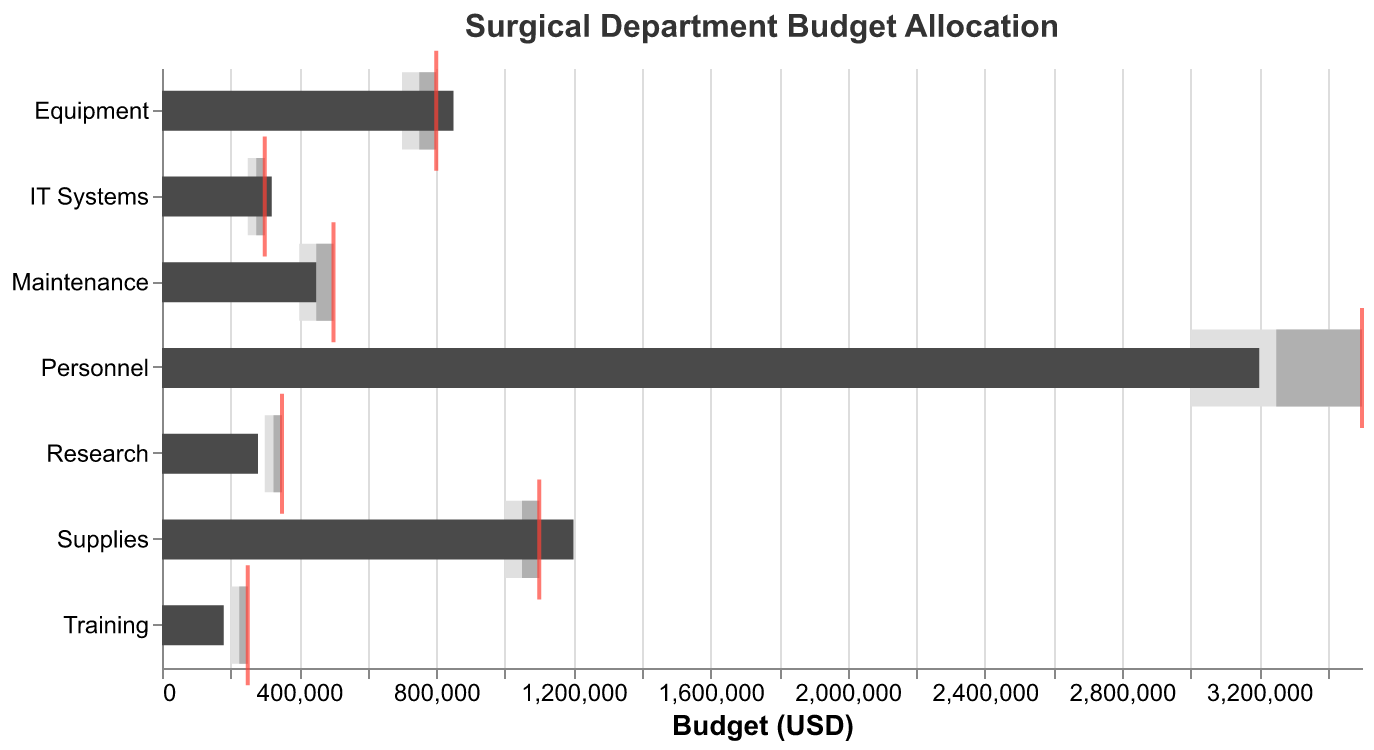What is the actual expenditure on personnel compared to its target? The actual expenditure on personnel is $3,200,000, while the target is $3,500,000. The actual value is indicated by the dark gray bar, and the target by the red tick mark.
Answer: $3,200,000 vs $3,500,000 Which category has the highest actual expenditure? The category with the highest actual expenditure is Personnel, with $3,200,000. This can be seen by comparing the length of the dark gray bars for each category.
Answer: Personnel Did the actual expenditure on equipment meet the target? Yes, the actual expenditure on equipment exceeded the target. The actual expenditure is $850,000, and the target is $800,000, as indicated by the dark gray bar surpassing the red tick mark.
Answer: Yes How much more did the actual expenditure on supplies exceed its target? The actual expenditure on supplies is $1,200,000, while the target is $1,100,000. The difference is calculated as $1,200,000 - $1,100,000 = $100,000.
Answer: $100,000 In which categories did the actual expenditure not meet the threshold 1 value? The categories where the actual expenditure did not meet the threshold 1 value are Training and Research. This can be seen because the dark gray bars for these categories do not reach the left edge of the lightest gray bars.
Answer: Training, Research What is the difference between the actual and target expenditure for training? The actual expenditure for training is $180,000, and the target is $250,000. The difference is calculated as $250,000 - $180,000 = $70,000.
Answer: $70,000 Which category has the smallest gap between actual and target expenditure? The IT Systems category has the smallest gap between actual ($320,000) and target expenditure ($300,000), which is $20,000.
Answer: IT Systems How many categories have actual expenditures that are above their respective target values? The categories with actual expenditures above their respective target values are Equipment, Supplies, and IT Systems, making a total of three categories. This can be observed by noting where the dark gray bars (actual) exceed the red tick marks (target).
Answer: 3 For the Research category, how does the actual expenditure compare to each of the thresholds? The actual expenditure for Research is $280,000. It is below Threshold 1 ($300,000), Threshold 2 ($325,000), and Threshold 3 ($350,000).
Answer: Below all thresholds 